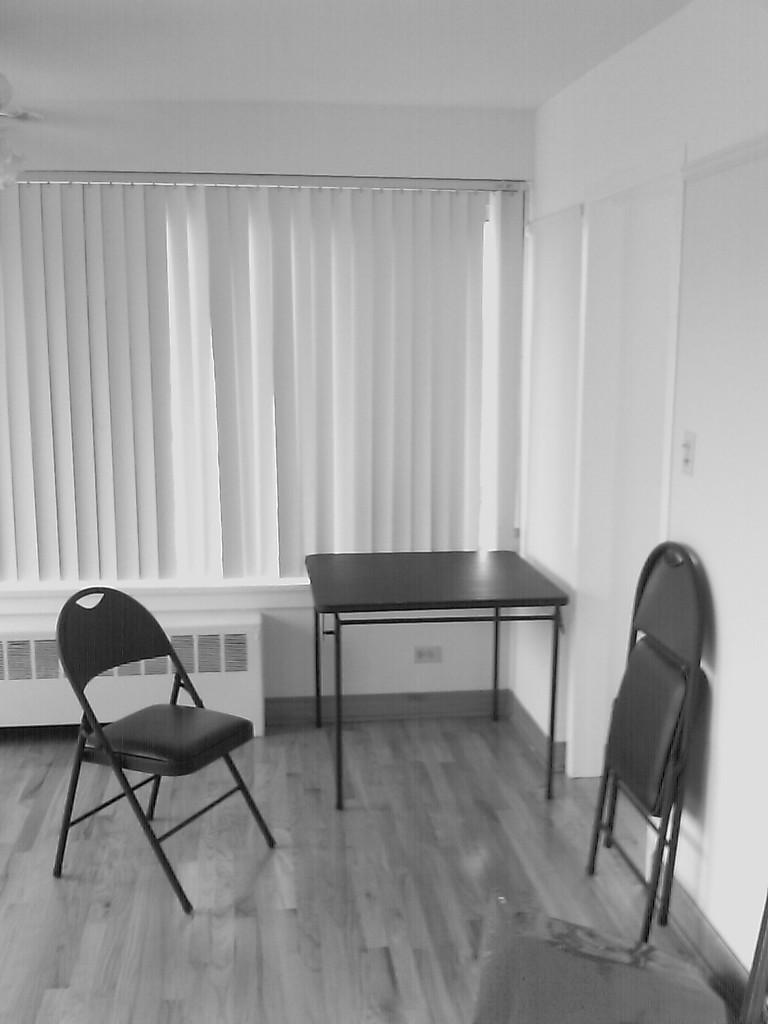How many chairs are visible in the image? There are two chairs in the image. What other piece of furniture is present in the image? There is a table in the image. What type of surface is visible beneath the furniture? The image shows a floor. Is there any source of natural light in the image? Yes, there is a window in the image. What type of rake is leaning against the wall in the image? There is no rake present in the image. How many wings can be seen on the chairs in the image? The chairs in the image do not have wings. 